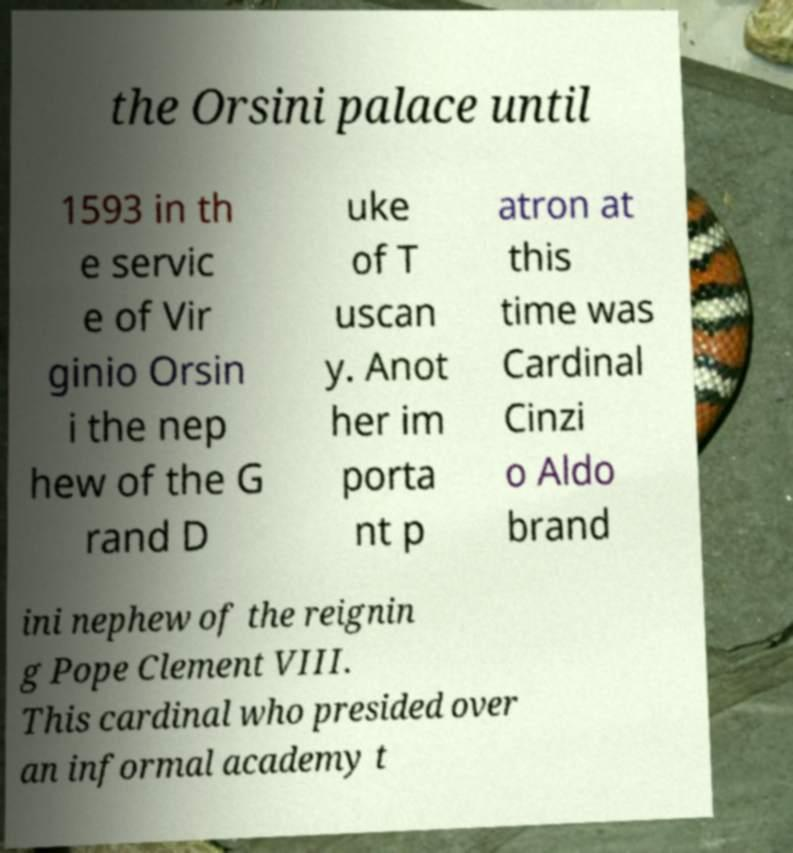Please read and relay the text visible in this image. What does it say? the Orsini palace until 1593 in th e servic e of Vir ginio Orsin i the nep hew of the G rand D uke of T uscan y. Anot her im porta nt p atron at this time was Cardinal Cinzi o Aldo brand ini nephew of the reignin g Pope Clement VIII. This cardinal who presided over an informal academy t 